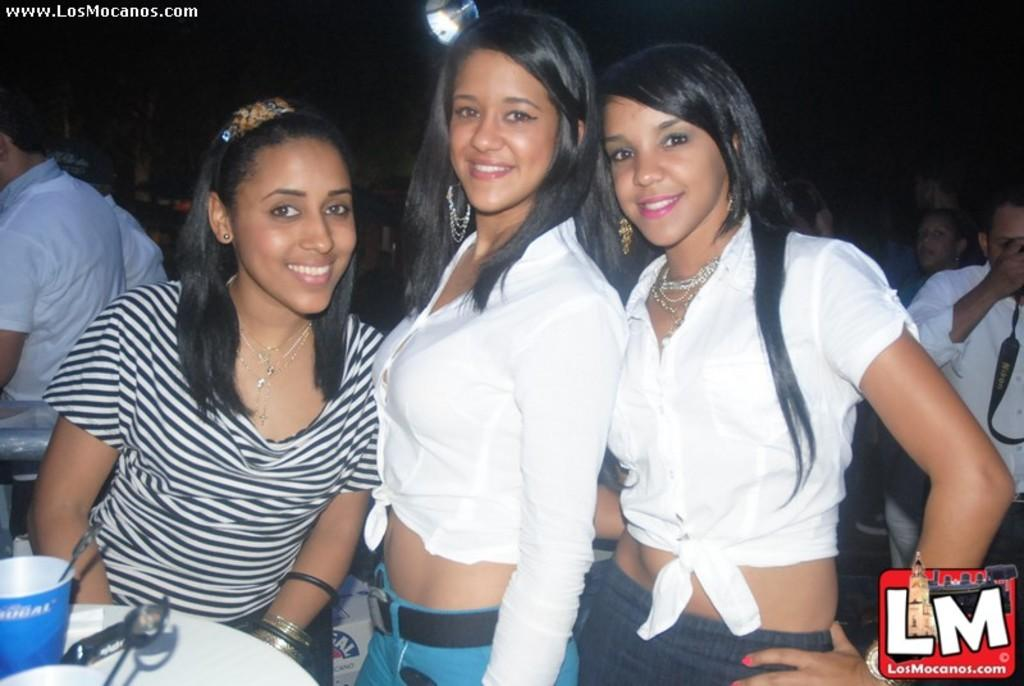<image>
Provide a brief description of the given image. Three women posing for a photo with the letters LM on the bottom. 